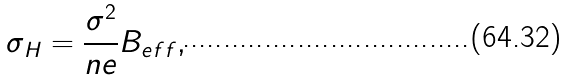<formula> <loc_0><loc_0><loc_500><loc_500>\sigma _ { H } = \frac { \sigma ^ { 2 } } { n e } B _ { e f f } ,</formula> 